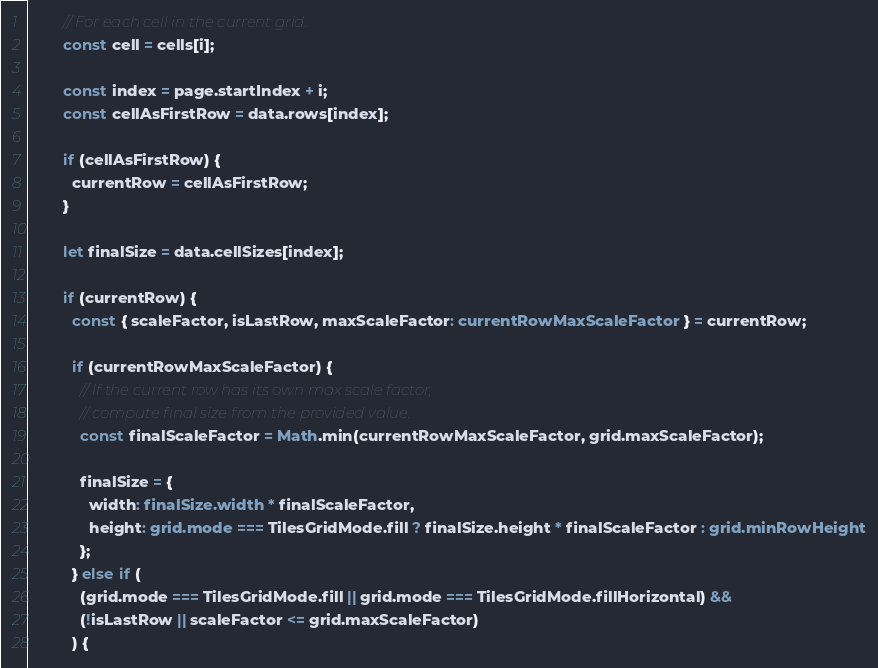<code> <loc_0><loc_0><loc_500><loc_500><_TypeScript_>        // For each cell in the current grid.
        const cell = cells[i];

        const index = page.startIndex + i;
        const cellAsFirstRow = data.rows[index];

        if (cellAsFirstRow) {
          currentRow = cellAsFirstRow;
        }

        let finalSize = data.cellSizes[index];

        if (currentRow) {
          const { scaleFactor, isLastRow, maxScaleFactor: currentRowMaxScaleFactor } = currentRow;

          if (currentRowMaxScaleFactor) {
            // If the current row has its own max scale factor,
            // compute final size from the provided value.
            const finalScaleFactor = Math.min(currentRowMaxScaleFactor, grid.maxScaleFactor);

            finalSize = {
              width: finalSize.width * finalScaleFactor,
              height: grid.mode === TilesGridMode.fill ? finalSize.height * finalScaleFactor : grid.minRowHeight
            };
          } else if (
            (grid.mode === TilesGridMode.fill || grid.mode === TilesGridMode.fillHorizontal) &&
            (!isLastRow || scaleFactor <= grid.maxScaleFactor)
          ) {</code> 